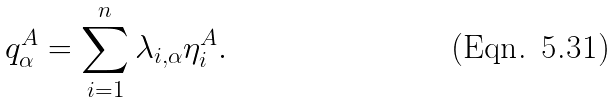Convert formula to latex. <formula><loc_0><loc_0><loc_500><loc_500>q _ { \alpha } ^ { A } = \sum _ { i = 1 } ^ { n } \lambda _ { i , \alpha } \eta _ { i } ^ { A } .</formula> 